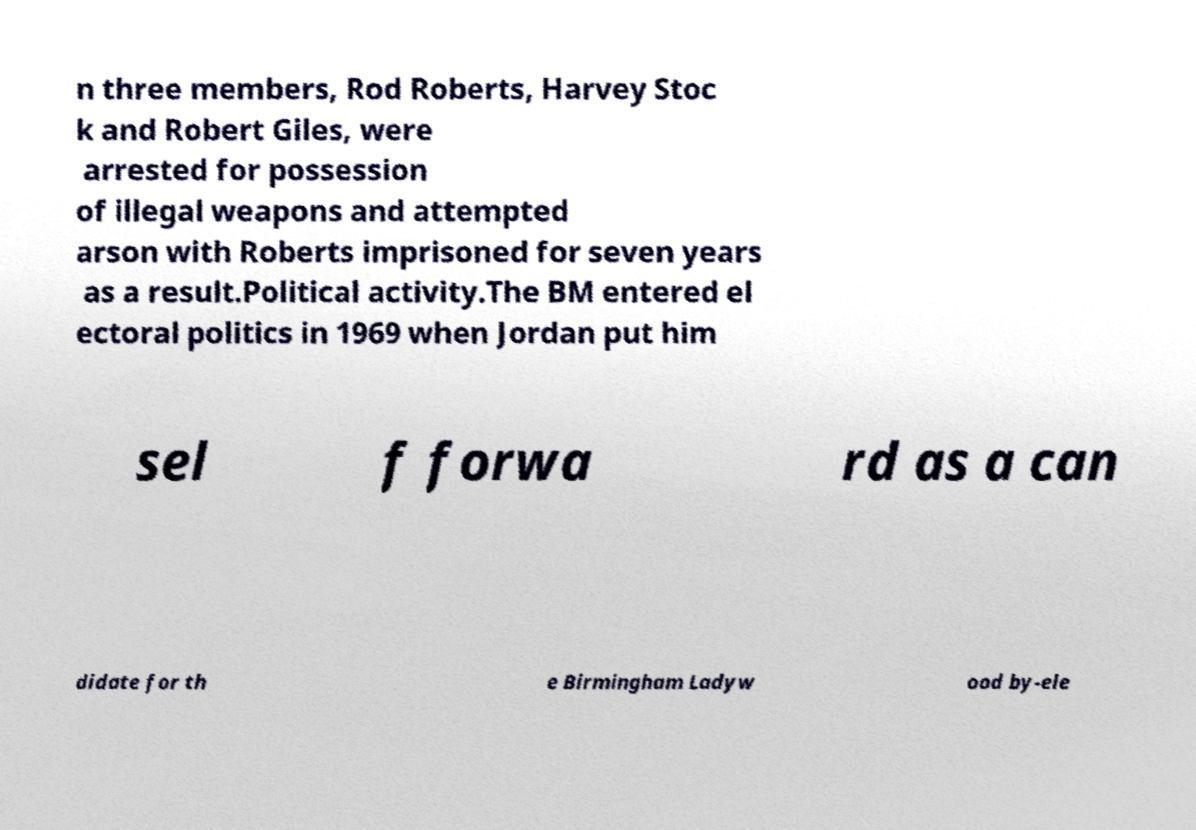There's text embedded in this image that I need extracted. Can you transcribe it verbatim? n three members, Rod Roberts, Harvey Stoc k and Robert Giles, were arrested for possession of illegal weapons and attempted arson with Roberts imprisoned for seven years as a result.Political activity.The BM entered el ectoral politics in 1969 when Jordan put him sel f forwa rd as a can didate for th e Birmingham Ladyw ood by-ele 